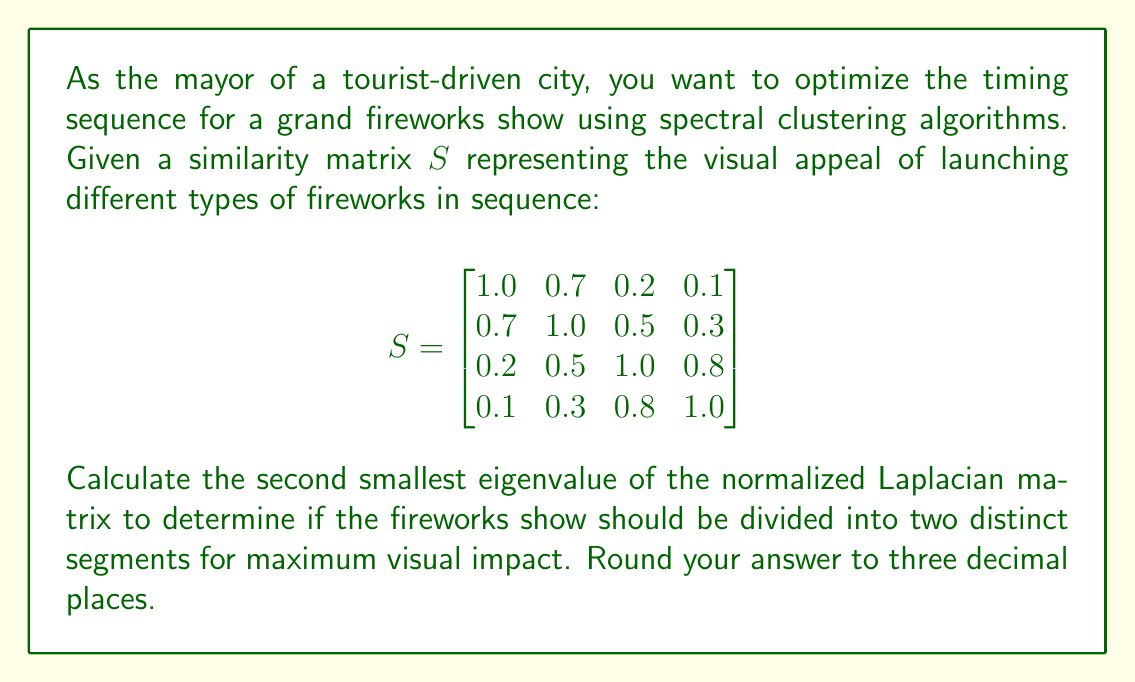Teach me how to tackle this problem. To solve this problem, we'll follow these steps:

1) First, we need to calculate the degree matrix $D$. The degree of each node is the sum of its row in the similarity matrix $S$:

   $$D = \begin{bmatrix}
   2.0 & 0 & 0 & 0 \\
   0 & 2.5 & 0 & 0 \\
   0 & 0 & 2.5 & 0 \\
   0 & 0 & 0 & 2.2
   \end{bmatrix}$$

2) Next, we calculate the Laplacian matrix $L = D - S$:

   $$L = \begin{bmatrix}
   1.0 & -0.7 & -0.2 & -0.1 \\
   -0.7 & 1.5 & -0.5 & -0.3 \\
   -0.2 & -0.5 & 1.5 & -0.8 \\
   -0.1 & -0.3 & -0.8 & 1.2
   \end{bmatrix}$$

3) Now, we need to calculate the normalized Laplacian $L_{norm} = D^{-1/2}LD^{-1/2}$:

   $$L_{norm} = \begin{bmatrix}
   1 & -0.4950 & -0.1414 & -0.0714 \\
   -0.4950 & 1 & -0.3333 & -0.2020 \\
   -0.1414 & -0.3333 & 1 & -0.5396 \\
   -0.0714 & -0.2020 & -0.5396 & 1
   \end{bmatrix}$$

4) We need to find the eigenvalues of $L_{norm}$. Using a computer algebra system or numerical methods, we can calculate these eigenvalues:

   $$\lambda_1 \approx 0.0000$$
   $$\lambda_2 \approx 0.2479$$
   $$\lambda_3 \approx 1.0000$$
   $$\lambda_4 \approx 2.7521$$

5) The second smallest eigenvalue is $\lambda_2 \approx 0.2479$.

6) Rounding to three decimal places, we get 0.248.
Answer: 0.248 